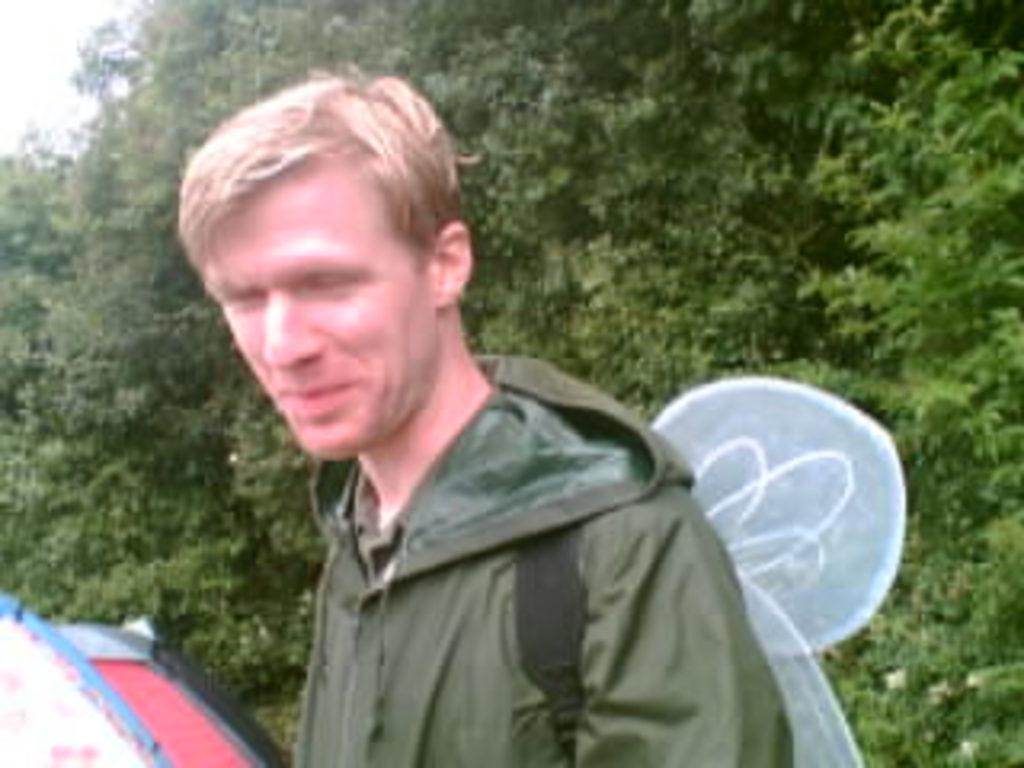Who is present in the image? There is a man in the image. What is the man wearing? The man is wearing a green jacket. What is the man doing in the image? The man is carrying something. What can be seen in the background of the image? There are trees and the sky visible in the background of the image. What type of development is the man attempting to sell in the image? There is no indication in the image that the man is selling any development or attempting to sell anything. 